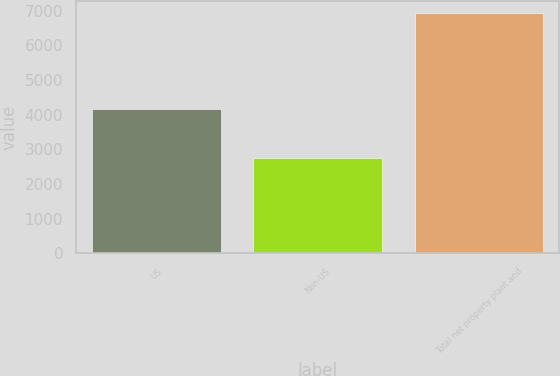Convert chart to OTSL. <chart><loc_0><loc_0><loc_500><loc_500><bar_chart><fcel>US<fcel>Non-US<fcel>Total net property plant and<nl><fcel>4158<fcel>2766<fcel>6924<nl></chart> 